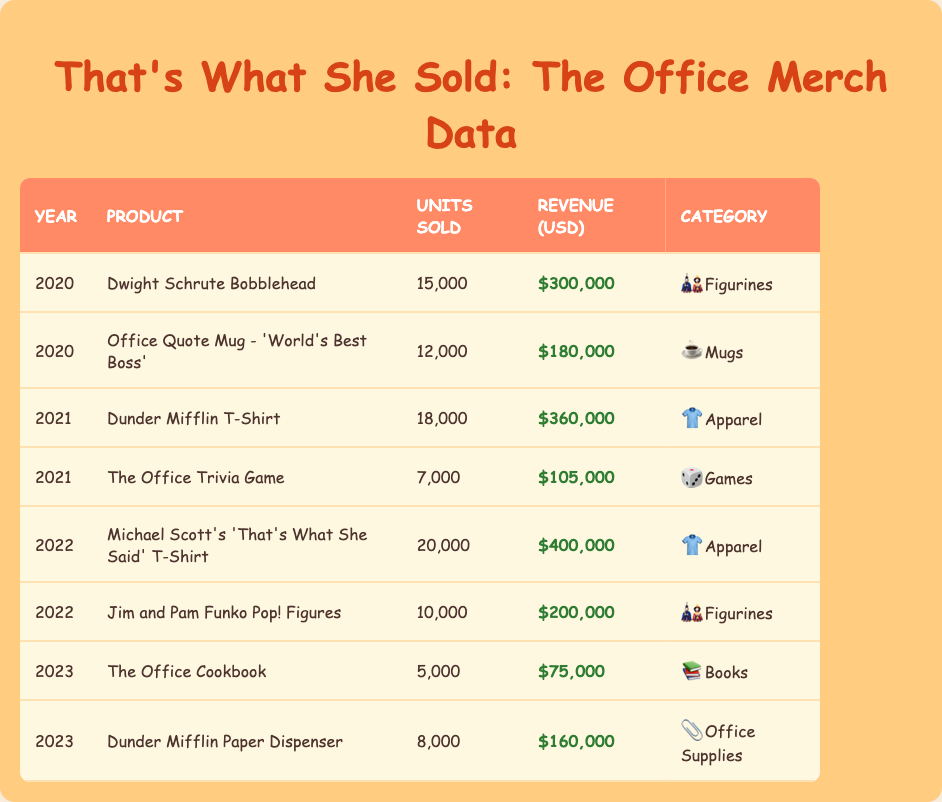What was the total revenue from merchandise sales in 2021? In 2021, there are two products: Dunder Mifflin T-Shirt with revenue of 360000 USD and The Office Trivia Game with revenue of 105000 USD. Adding these together gives us a total revenue of 360000 + 105000 = 465000 USD.
Answer: 465000 USD Which product had the highest units sold in 2022? The data for 2022 shows two products: Michael Scott's 'That's What She Said' T-Shirt with units sold of 20000 and Jim and Pam Funko Pop! Figures with units sold of 10000. Since 20000 is greater than 10000, the Michael Scott's T-Shirt had the highest units sold.
Answer: Michael Scott's 'That's What She Said' T-Shirt Did more units of the Dunder Mifflin T-Shirt sell than the Dwight Schrute Bobblehead from 2020? In 2020, the Dwight Schrute Bobblehead sold 15000 units, while the Dunder Mifflin T-Shirt was sold in 2021 with 18000 units. Thus, 18000 is greater than 15000, confirming that the Dunder Mifflin T-Shirt sold more.
Answer: Yes What was the average revenue from merchandise sales across all products in 2020? For 2020, there are two products: the Dwight Schrute Bobblehead with revenue of 300000 USD and the Office Quote Mug with revenue of 180000 USD. The total revenue is 300000 + 180000 = 480000 USD. Since there are 2 products, the average revenue is 480000 / 2 = 240000 USD.
Answer: 240000 USD Which year had the lowest total units sold? To find the year with the lowest total units sold, we can sum the units sold per year. For 2020: 15000 + 12000 = 27000; for 2021: 18000 + 7000 = 25000; for 2022: 20000 + 10000 = 30000; and for 2023: 5000 + 8000 = 13000. Comparing these totals, we find that 13000 in 2023 is the lowest.
Answer: 2023 What category sold the most units overall from 2020 to 2023? We need to sum the units sold for each product by category across all years. For Figurines: 15000 (2020) + 10000 (2022) = 25000; for Mugs: 12000 (2020); for Apparel: 18000 (2021) + 20000 (2022) = 38000; for Games: 7000 (2021); for Books: 5000 (2023); for Office Supplies: 8000 (2023). The Apparel category has the highest total units sold, which is 38000.
Answer: Apparel Was there any product that sold fewer than 10000 units in 2023? The data for 2023 shows The Office Cookbook, which sold 5000 units, and the Dunder Mifflin Paper Dispenser sold 8000 units. Both are below 10000 units, confirming that there were products that sold fewer than 10000 units.
Answer: Yes What is the total revenue from products sold in the Figurines category? The Figurines category includes the Dwight Schrute Bobblehead from 2020 with 300000 USD and Jim and Pam Funko Pop! Figures from 2022 with 200000 USD. The total revenue is calculated by adding these amounts: 300000 + 200000 = 500000 USD.
Answer: 500000 USD 